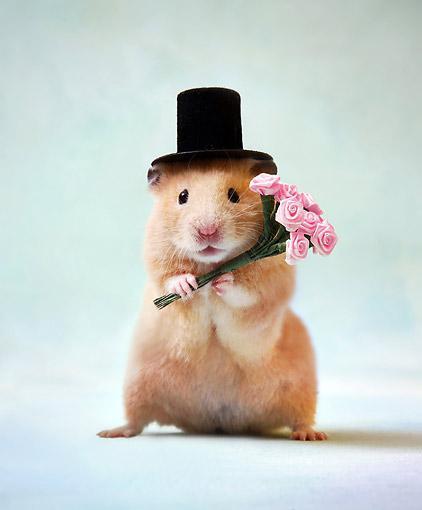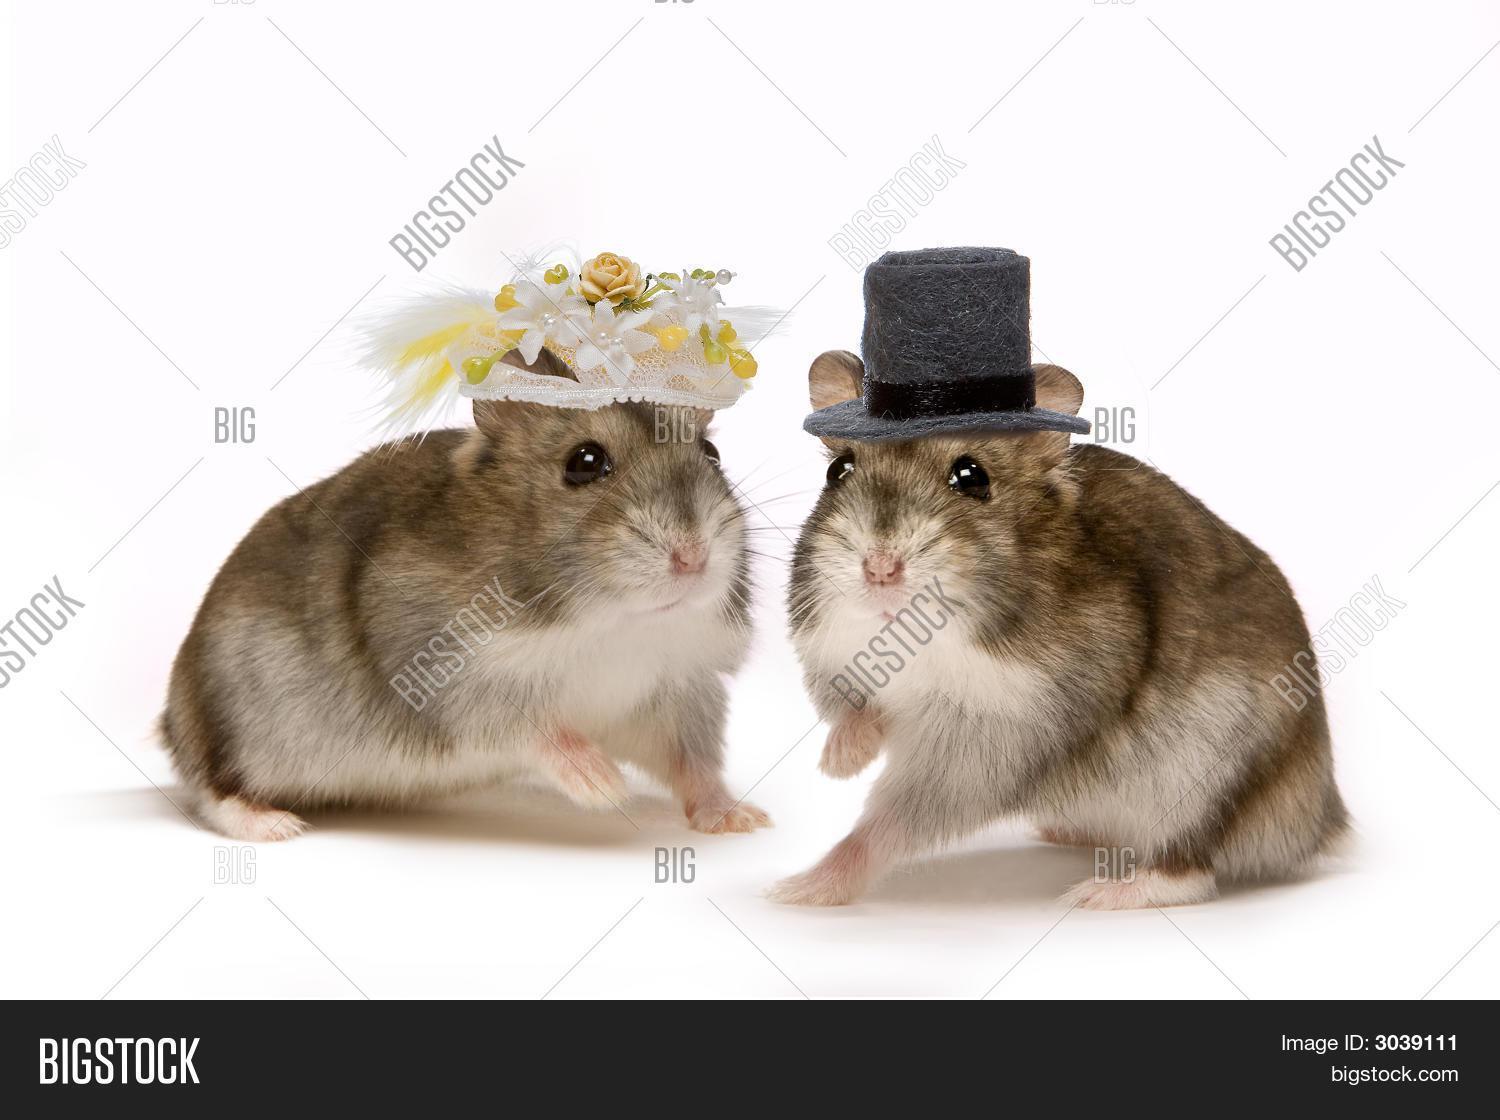The first image is the image on the left, the second image is the image on the right. Considering the images on both sides, is "The rodent in the image on the left is standing while wearing a top hat." valid? Answer yes or no. Yes. The first image is the image on the left, the second image is the image on the right. Considering the images on both sides, is "Exactly one guinea pig is wearing a top hat." valid? Answer yes or no. No. 